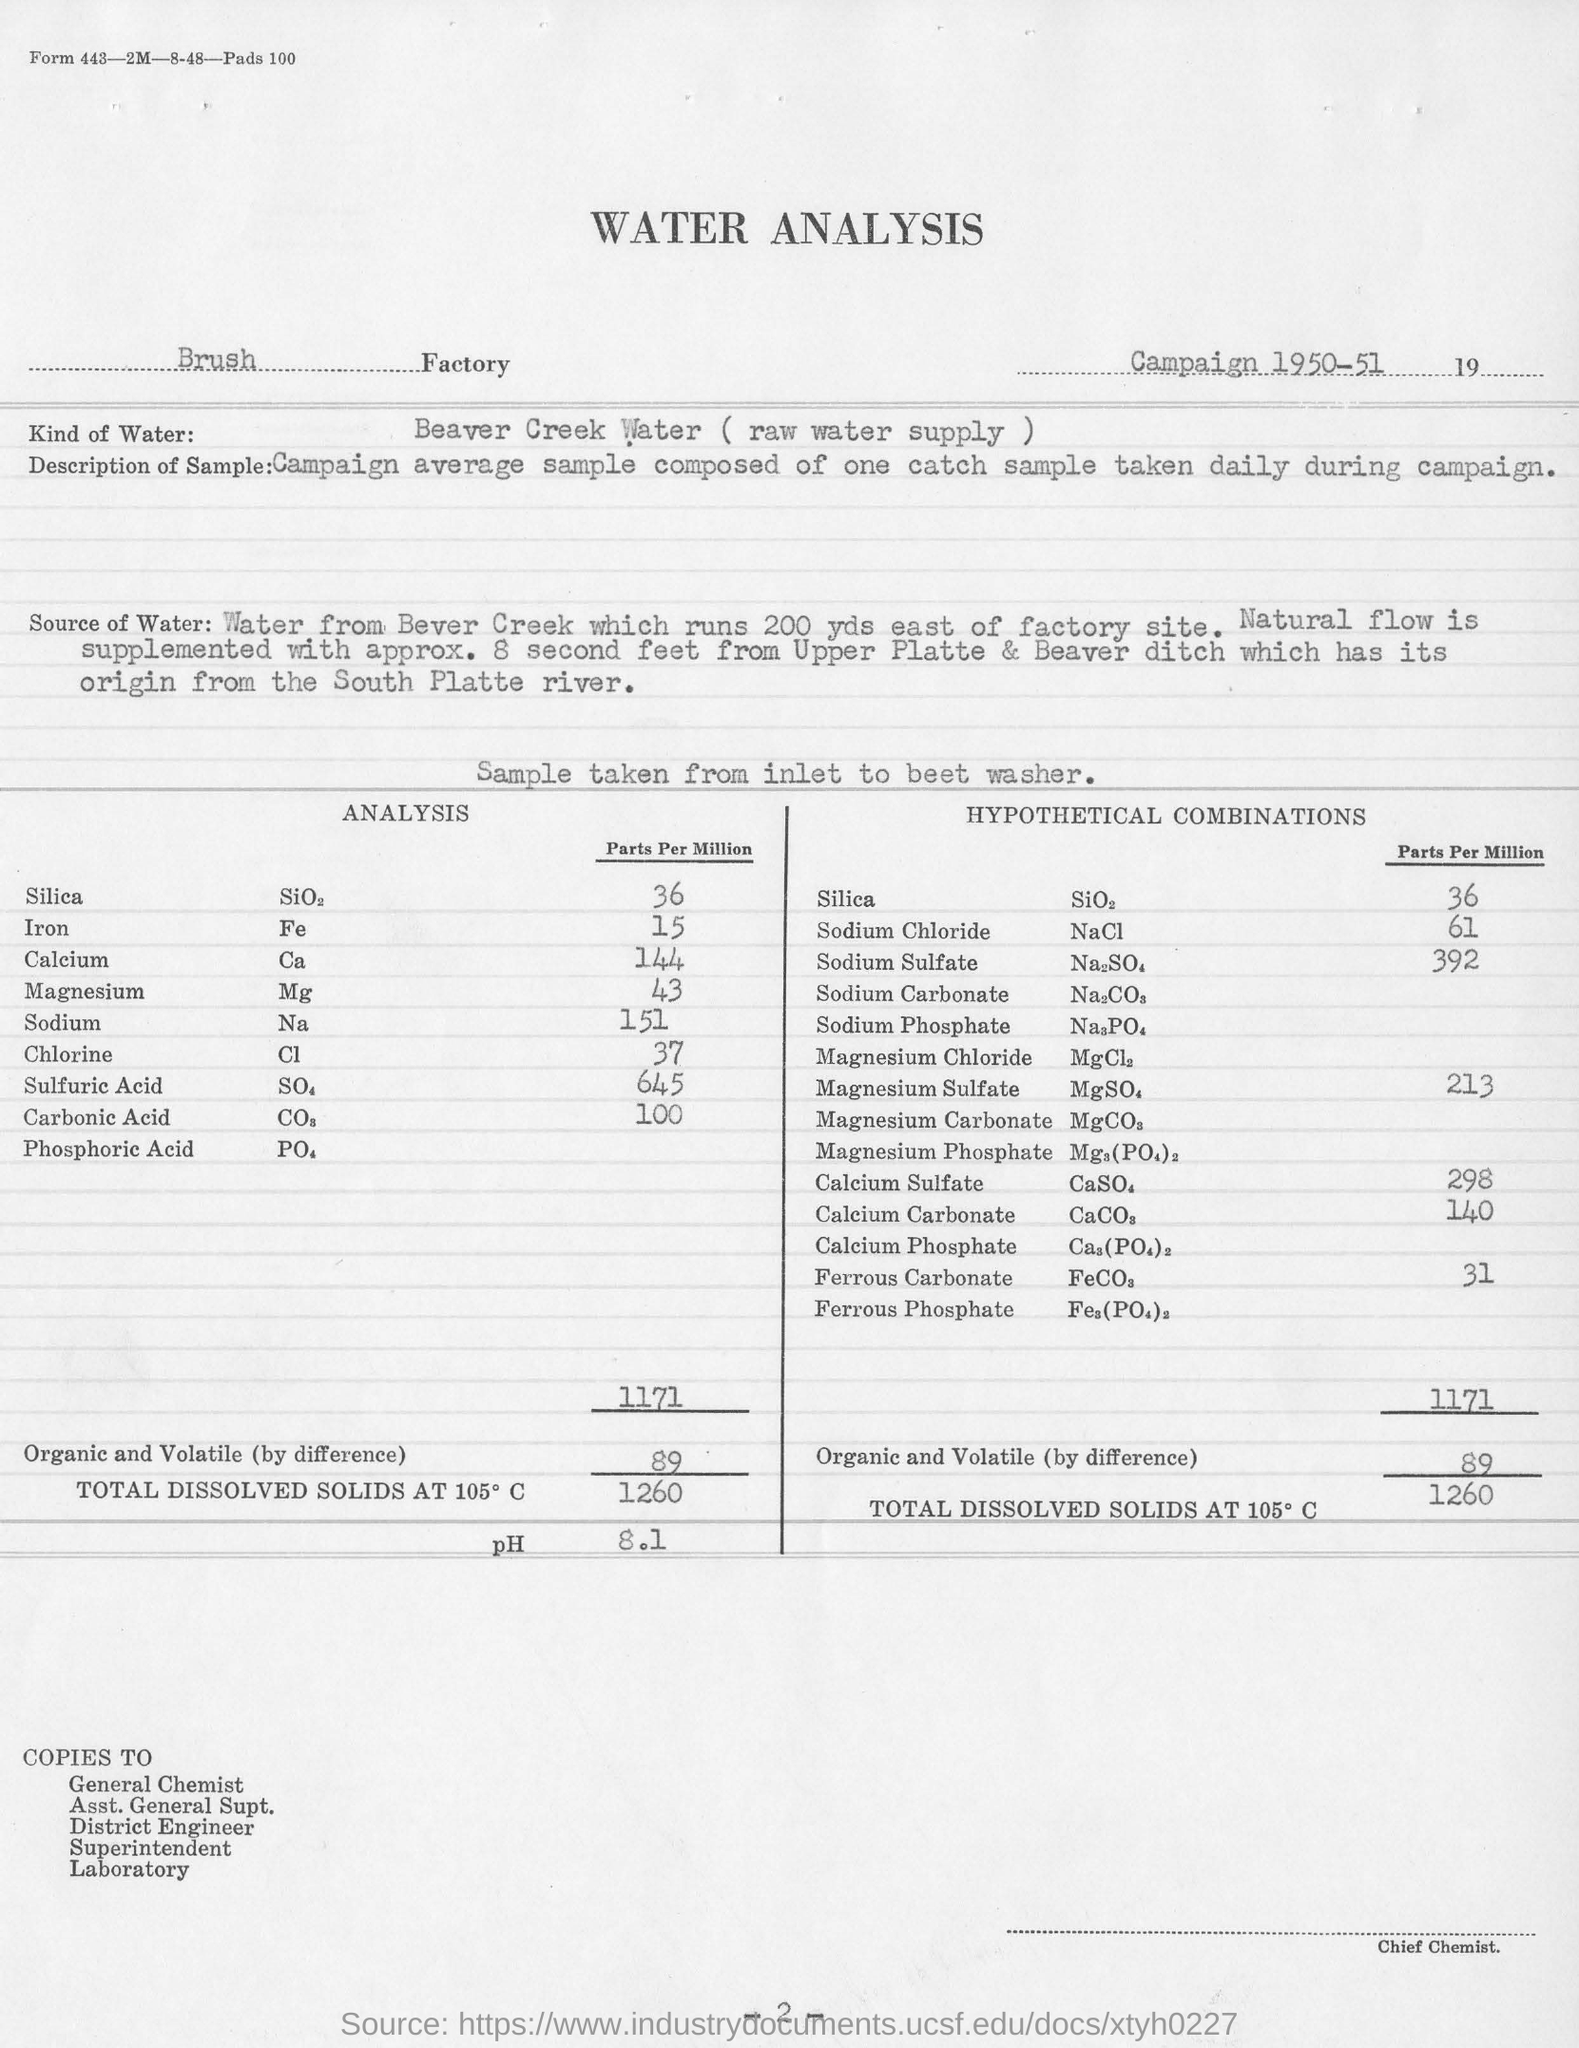List a handful of essential elements in this visual. The water analysis was conducted at the Brush factory. The sample of water was obtained from Beaver Creek. The analysis used Beaver Creek Water (raw water supply) as the type of water. The pH value mentioned is 8.1. 